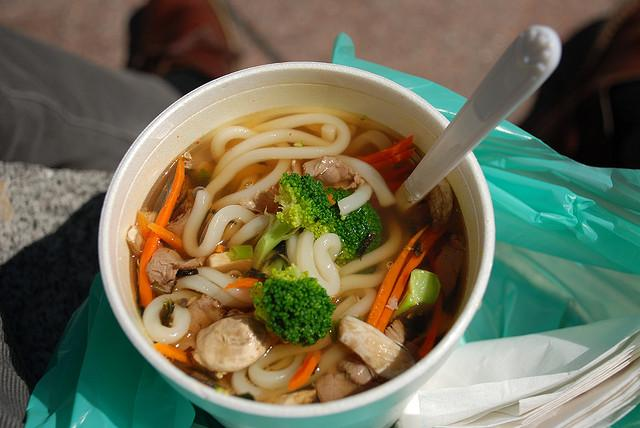What country do the noodles originate from? Please explain your reasoning. china. China invented the noodles. 